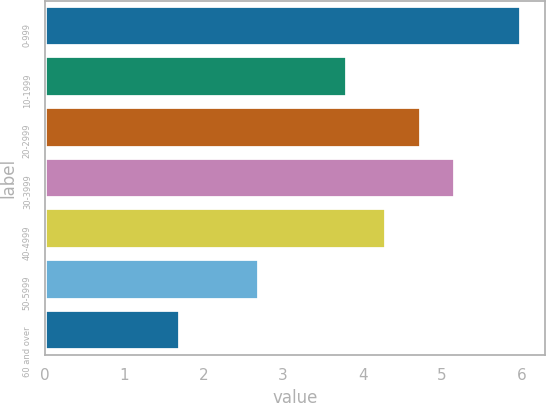<chart> <loc_0><loc_0><loc_500><loc_500><bar_chart><fcel>0-999<fcel>10-1999<fcel>20-2999<fcel>30-3999<fcel>40-4999<fcel>50-5999<fcel>60 and over<nl><fcel>6<fcel>3.8<fcel>4.73<fcel>5.16<fcel>4.3<fcel>2.7<fcel>1.7<nl></chart> 